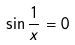Convert formula to latex. <formula><loc_0><loc_0><loc_500><loc_500>\sin \frac { 1 } { x } = 0</formula> 